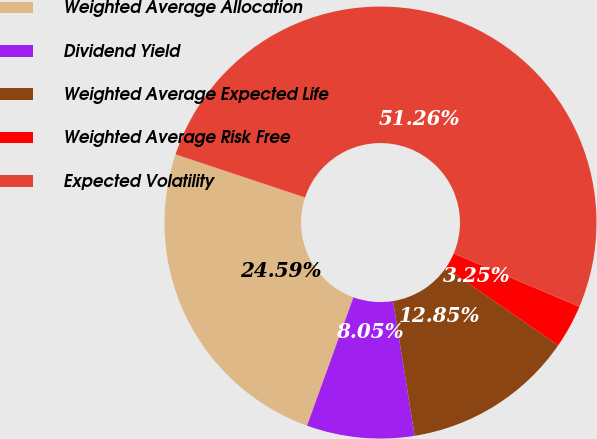Convert chart. <chart><loc_0><loc_0><loc_500><loc_500><pie_chart><fcel>Weighted Average Allocation<fcel>Dividend Yield<fcel>Weighted Average Expected Life<fcel>Weighted Average Risk Free<fcel>Expected Volatility<nl><fcel>24.59%<fcel>8.05%<fcel>12.85%<fcel>3.25%<fcel>51.26%<nl></chart> 